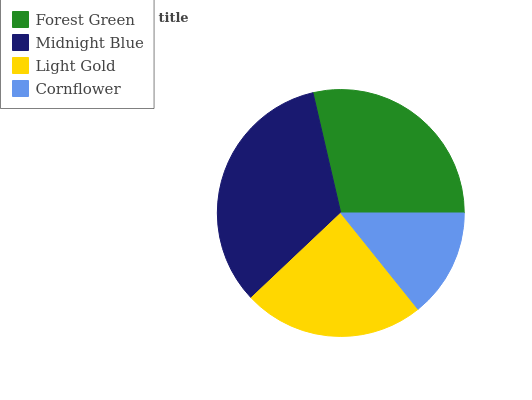Is Cornflower the minimum?
Answer yes or no. Yes. Is Midnight Blue the maximum?
Answer yes or no. Yes. Is Light Gold the minimum?
Answer yes or no. No. Is Light Gold the maximum?
Answer yes or no. No. Is Midnight Blue greater than Light Gold?
Answer yes or no. Yes. Is Light Gold less than Midnight Blue?
Answer yes or no. Yes. Is Light Gold greater than Midnight Blue?
Answer yes or no. No. Is Midnight Blue less than Light Gold?
Answer yes or no. No. Is Forest Green the high median?
Answer yes or no. Yes. Is Light Gold the low median?
Answer yes or no. Yes. Is Light Gold the high median?
Answer yes or no. No. Is Midnight Blue the low median?
Answer yes or no. No. 